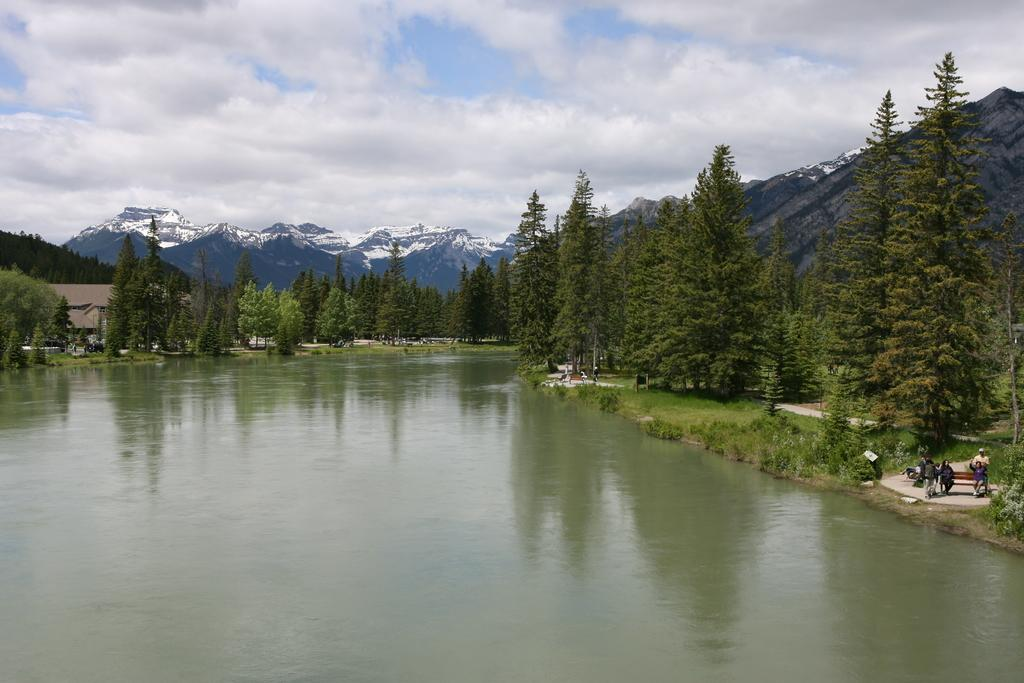What is at the bottom of the image? There is water at the bottom of the image. What can be seen near the water? There are people standing near the water. What is located in the middle of the image? There are trees, hills, and buildings in the middle of the image. What book is being read by the trees in the image? There is no book present in the image, as the trees are not capable of reading. What type of destruction can be seen in the image? There is no destruction present in the image; it features water, people, trees, hills, and buildings. 